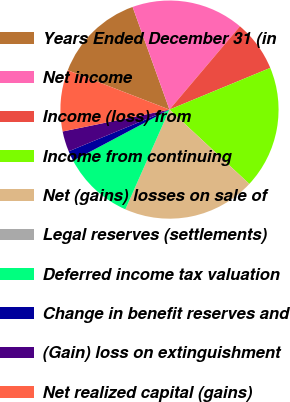<chart> <loc_0><loc_0><loc_500><loc_500><pie_chart><fcel>Years Ended December 31 (in<fcel>Net income<fcel>Income (loss) from<fcel>Income from continuing<fcel>Net (gains) losses on sale of<fcel>Legal reserves (settlements)<fcel>Deferred income tax valuation<fcel>Change in benefit reserves and<fcel>(Gain) loss on extinguishment<fcel>Net realized capital (gains)<nl><fcel>13.64%<fcel>16.67%<fcel>7.58%<fcel>18.18%<fcel>19.7%<fcel>0.0%<fcel>10.61%<fcel>1.52%<fcel>3.03%<fcel>9.09%<nl></chart> 